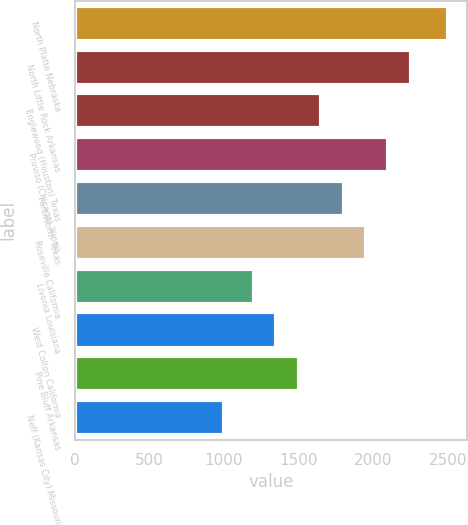Convert chart to OTSL. <chart><loc_0><loc_0><loc_500><loc_500><bar_chart><fcel>North Platte Nebraska<fcel>North Little Rock Arkansas<fcel>Englewood (Houston) Texas<fcel>Proviso (Chicago) Illinois<fcel>Fort Worth Texas<fcel>Roseville California<fcel>Livonia Louisiana<fcel>West Colton California<fcel>Pine Bluff Arkansas<fcel>Neff (Kansas City) Missouri<nl><fcel>2500<fcel>2250<fcel>1650<fcel>2100<fcel>1800<fcel>1950<fcel>1200<fcel>1350<fcel>1500<fcel>1000<nl></chart> 